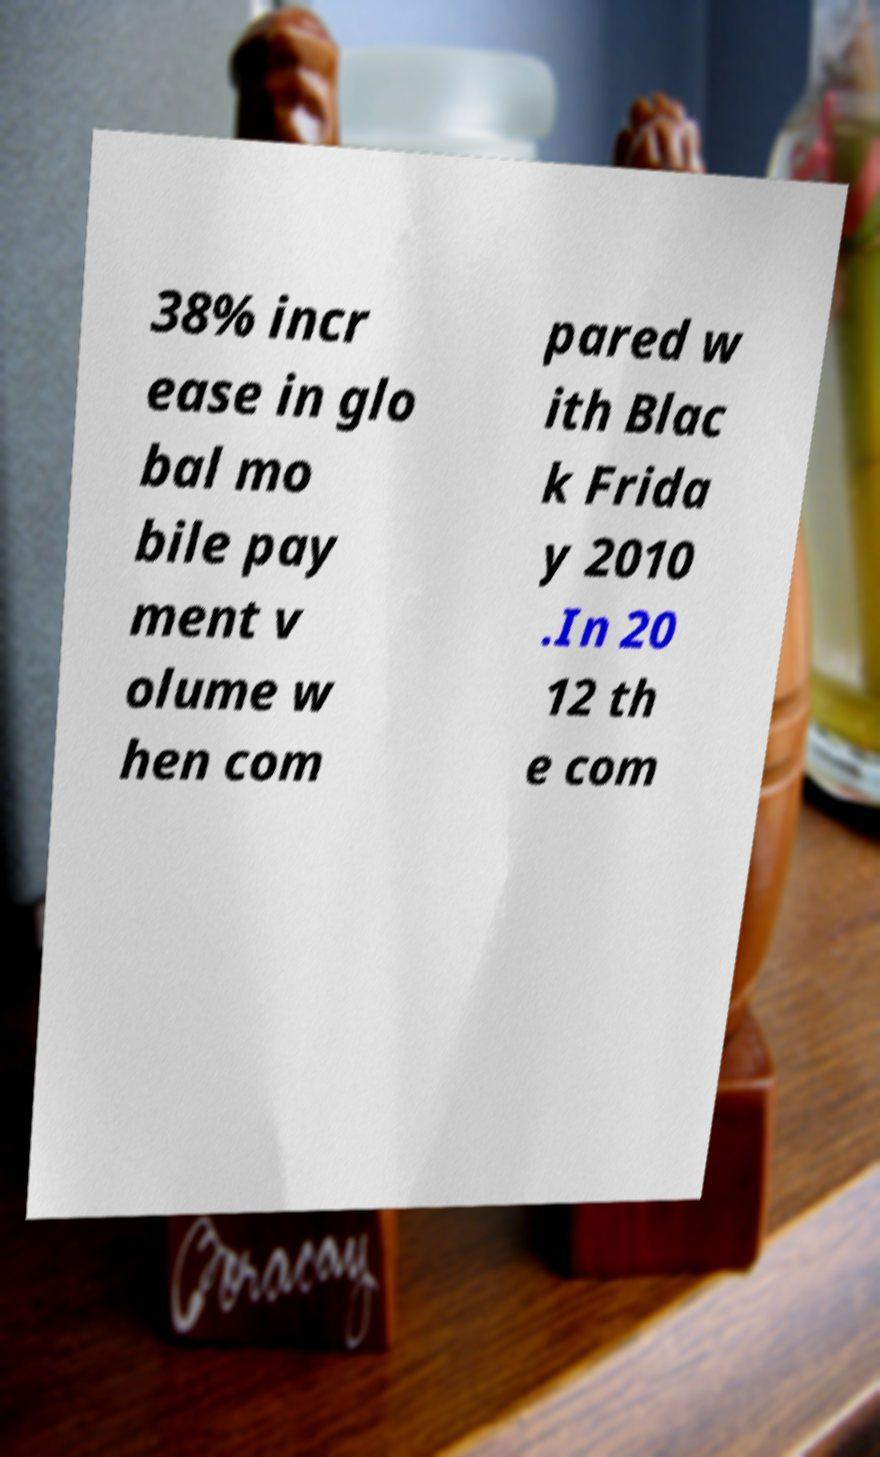Can you read and provide the text displayed in the image?This photo seems to have some interesting text. Can you extract and type it out for me? 38% incr ease in glo bal mo bile pay ment v olume w hen com pared w ith Blac k Frida y 2010 .In 20 12 th e com 